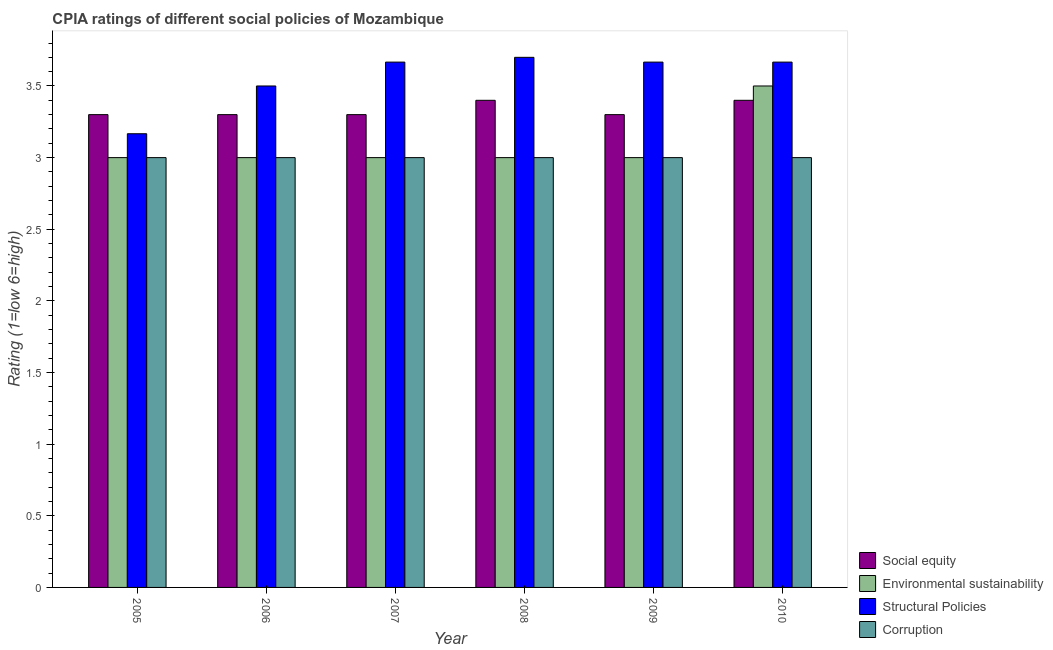How many groups of bars are there?
Give a very brief answer. 6. Are the number of bars per tick equal to the number of legend labels?
Make the answer very short. Yes. Are the number of bars on each tick of the X-axis equal?
Offer a very short reply. Yes. How many bars are there on the 2nd tick from the right?
Ensure brevity in your answer.  4. What is the label of the 4th group of bars from the left?
Your answer should be very brief. 2008. What is the cpia rating of structural policies in 2006?
Offer a very short reply. 3.5. Across all years, what is the maximum cpia rating of corruption?
Provide a succinct answer. 3. Across all years, what is the minimum cpia rating of corruption?
Your answer should be very brief. 3. What is the difference between the cpia rating of social equity in 2005 and that in 2010?
Give a very brief answer. -0.1. What is the difference between the cpia rating of social equity in 2007 and the cpia rating of corruption in 2006?
Offer a very short reply. 0. What is the average cpia rating of structural policies per year?
Ensure brevity in your answer.  3.56. In how many years, is the cpia rating of structural policies greater than 1.7?
Offer a terse response. 6. Is the cpia rating of corruption in 2009 less than that in 2010?
Provide a short and direct response. No. Is the difference between the cpia rating of environmental sustainability in 2008 and 2009 greater than the difference between the cpia rating of social equity in 2008 and 2009?
Provide a short and direct response. No. What is the difference between the highest and the lowest cpia rating of corruption?
Ensure brevity in your answer.  0. What does the 3rd bar from the left in 2005 represents?
Provide a short and direct response. Structural Policies. What does the 4th bar from the right in 2005 represents?
Ensure brevity in your answer.  Social equity. How many bars are there?
Your answer should be compact. 24. How many years are there in the graph?
Give a very brief answer. 6. Does the graph contain any zero values?
Offer a terse response. No. Does the graph contain grids?
Provide a succinct answer. No. What is the title of the graph?
Provide a succinct answer. CPIA ratings of different social policies of Mozambique. Does "Belgium" appear as one of the legend labels in the graph?
Your answer should be very brief. No. What is the Rating (1=low 6=high) of Environmental sustainability in 2005?
Offer a terse response. 3. What is the Rating (1=low 6=high) in Structural Policies in 2005?
Keep it short and to the point. 3.17. What is the Rating (1=low 6=high) of Corruption in 2005?
Give a very brief answer. 3. What is the Rating (1=low 6=high) of Social equity in 2006?
Your answer should be compact. 3.3. What is the Rating (1=low 6=high) of Environmental sustainability in 2006?
Offer a very short reply. 3. What is the Rating (1=low 6=high) of Structural Policies in 2006?
Keep it short and to the point. 3.5. What is the Rating (1=low 6=high) of Corruption in 2006?
Provide a succinct answer. 3. What is the Rating (1=low 6=high) in Social equity in 2007?
Provide a short and direct response. 3.3. What is the Rating (1=low 6=high) in Environmental sustainability in 2007?
Your answer should be compact. 3. What is the Rating (1=low 6=high) of Structural Policies in 2007?
Make the answer very short. 3.67. What is the Rating (1=low 6=high) of Environmental sustainability in 2009?
Offer a very short reply. 3. What is the Rating (1=low 6=high) in Structural Policies in 2009?
Your response must be concise. 3.67. What is the Rating (1=low 6=high) in Social equity in 2010?
Your answer should be very brief. 3.4. What is the Rating (1=low 6=high) in Environmental sustainability in 2010?
Your answer should be compact. 3.5. What is the Rating (1=low 6=high) of Structural Policies in 2010?
Ensure brevity in your answer.  3.67. What is the Rating (1=low 6=high) in Corruption in 2010?
Your response must be concise. 3. Across all years, what is the maximum Rating (1=low 6=high) of Social equity?
Provide a succinct answer. 3.4. Across all years, what is the maximum Rating (1=low 6=high) in Environmental sustainability?
Your answer should be compact. 3.5. Across all years, what is the maximum Rating (1=low 6=high) in Structural Policies?
Your response must be concise. 3.7. Across all years, what is the minimum Rating (1=low 6=high) in Social equity?
Make the answer very short. 3.3. Across all years, what is the minimum Rating (1=low 6=high) of Environmental sustainability?
Ensure brevity in your answer.  3. Across all years, what is the minimum Rating (1=low 6=high) in Structural Policies?
Provide a succinct answer. 3.17. Across all years, what is the minimum Rating (1=low 6=high) in Corruption?
Your answer should be compact. 3. What is the total Rating (1=low 6=high) of Environmental sustainability in the graph?
Your response must be concise. 18.5. What is the total Rating (1=low 6=high) in Structural Policies in the graph?
Ensure brevity in your answer.  21.37. What is the difference between the Rating (1=low 6=high) of Social equity in 2005 and that in 2006?
Your answer should be compact. 0. What is the difference between the Rating (1=low 6=high) in Structural Policies in 2005 and that in 2006?
Provide a short and direct response. -0.33. What is the difference between the Rating (1=low 6=high) in Corruption in 2005 and that in 2006?
Offer a very short reply. 0. What is the difference between the Rating (1=low 6=high) in Social equity in 2005 and that in 2007?
Your answer should be compact. 0. What is the difference between the Rating (1=low 6=high) in Structural Policies in 2005 and that in 2008?
Your response must be concise. -0.53. What is the difference between the Rating (1=low 6=high) of Corruption in 2005 and that in 2008?
Give a very brief answer. 0. What is the difference between the Rating (1=low 6=high) of Structural Policies in 2005 and that in 2009?
Give a very brief answer. -0.5. What is the difference between the Rating (1=low 6=high) in Corruption in 2005 and that in 2009?
Your answer should be compact. 0. What is the difference between the Rating (1=low 6=high) of Corruption in 2005 and that in 2010?
Keep it short and to the point. 0. What is the difference between the Rating (1=low 6=high) of Environmental sustainability in 2006 and that in 2007?
Ensure brevity in your answer.  0. What is the difference between the Rating (1=low 6=high) of Structural Policies in 2006 and that in 2007?
Keep it short and to the point. -0.17. What is the difference between the Rating (1=low 6=high) in Corruption in 2006 and that in 2007?
Provide a short and direct response. 0. What is the difference between the Rating (1=low 6=high) in Corruption in 2006 and that in 2008?
Provide a short and direct response. 0. What is the difference between the Rating (1=low 6=high) in Environmental sustainability in 2006 and that in 2009?
Offer a terse response. 0. What is the difference between the Rating (1=low 6=high) of Structural Policies in 2006 and that in 2009?
Offer a very short reply. -0.17. What is the difference between the Rating (1=low 6=high) in Environmental sustainability in 2006 and that in 2010?
Keep it short and to the point. -0.5. What is the difference between the Rating (1=low 6=high) in Structural Policies in 2007 and that in 2008?
Make the answer very short. -0.03. What is the difference between the Rating (1=low 6=high) of Structural Policies in 2007 and that in 2009?
Offer a terse response. 0. What is the difference between the Rating (1=low 6=high) of Structural Policies in 2007 and that in 2010?
Offer a very short reply. 0. What is the difference between the Rating (1=low 6=high) of Corruption in 2007 and that in 2010?
Provide a short and direct response. 0. What is the difference between the Rating (1=low 6=high) of Environmental sustainability in 2008 and that in 2009?
Offer a very short reply. 0. What is the difference between the Rating (1=low 6=high) of Environmental sustainability in 2008 and that in 2010?
Keep it short and to the point. -0.5. What is the difference between the Rating (1=low 6=high) of Structural Policies in 2008 and that in 2010?
Your answer should be compact. 0.03. What is the difference between the Rating (1=low 6=high) in Social equity in 2009 and that in 2010?
Your response must be concise. -0.1. What is the difference between the Rating (1=low 6=high) in Environmental sustainability in 2009 and that in 2010?
Provide a short and direct response. -0.5. What is the difference between the Rating (1=low 6=high) of Structural Policies in 2009 and that in 2010?
Offer a very short reply. 0. What is the difference between the Rating (1=low 6=high) of Corruption in 2009 and that in 2010?
Your answer should be compact. 0. What is the difference between the Rating (1=low 6=high) of Social equity in 2005 and the Rating (1=low 6=high) of Structural Policies in 2006?
Make the answer very short. -0.2. What is the difference between the Rating (1=low 6=high) in Social equity in 2005 and the Rating (1=low 6=high) in Corruption in 2006?
Your answer should be compact. 0.3. What is the difference between the Rating (1=low 6=high) of Structural Policies in 2005 and the Rating (1=low 6=high) of Corruption in 2006?
Give a very brief answer. 0.17. What is the difference between the Rating (1=low 6=high) of Social equity in 2005 and the Rating (1=low 6=high) of Structural Policies in 2007?
Offer a very short reply. -0.37. What is the difference between the Rating (1=low 6=high) of Environmental sustainability in 2005 and the Rating (1=low 6=high) of Structural Policies in 2007?
Offer a very short reply. -0.67. What is the difference between the Rating (1=low 6=high) in Structural Policies in 2005 and the Rating (1=low 6=high) in Corruption in 2007?
Give a very brief answer. 0.17. What is the difference between the Rating (1=low 6=high) in Environmental sustainability in 2005 and the Rating (1=low 6=high) in Structural Policies in 2008?
Your answer should be compact. -0.7. What is the difference between the Rating (1=low 6=high) in Environmental sustainability in 2005 and the Rating (1=low 6=high) in Corruption in 2008?
Your response must be concise. 0. What is the difference between the Rating (1=low 6=high) of Social equity in 2005 and the Rating (1=low 6=high) of Structural Policies in 2009?
Make the answer very short. -0.37. What is the difference between the Rating (1=low 6=high) of Social equity in 2005 and the Rating (1=low 6=high) of Structural Policies in 2010?
Give a very brief answer. -0.37. What is the difference between the Rating (1=low 6=high) of Environmental sustainability in 2005 and the Rating (1=low 6=high) of Structural Policies in 2010?
Your response must be concise. -0.67. What is the difference between the Rating (1=low 6=high) in Structural Policies in 2005 and the Rating (1=low 6=high) in Corruption in 2010?
Offer a very short reply. 0.17. What is the difference between the Rating (1=low 6=high) of Social equity in 2006 and the Rating (1=low 6=high) of Environmental sustainability in 2007?
Your answer should be very brief. 0.3. What is the difference between the Rating (1=low 6=high) in Social equity in 2006 and the Rating (1=low 6=high) in Structural Policies in 2007?
Make the answer very short. -0.37. What is the difference between the Rating (1=low 6=high) of Social equity in 2006 and the Rating (1=low 6=high) of Corruption in 2007?
Offer a very short reply. 0.3. What is the difference between the Rating (1=low 6=high) in Social equity in 2006 and the Rating (1=low 6=high) in Structural Policies in 2008?
Make the answer very short. -0.4. What is the difference between the Rating (1=low 6=high) in Structural Policies in 2006 and the Rating (1=low 6=high) in Corruption in 2008?
Your response must be concise. 0.5. What is the difference between the Rating (1=low 6=high) of Social equity in 2006 and the Rating (1=low 6=high) of Structural Policies in 2009?
Provide a succinct answer. -0.37. What is the difference between the Rating (1=low 6=high) in Environmental sustainability in 2006 and the Rating (1=low 6=high) in Structural Policies in 2009?
Your response must be concise. -0.67. What is the difference between the Rating (1=low 6=high) in Environmental sustainability in 2006 and the Rating (1=low 6=high) in Corruption in 2009?
Provide a succinct answer. 0. What is the difference between the Rating (1=low 6=high) in Social equity in 2006 and the Rating (1=low 6=high) in Environmental sustainability in 2010?
Your answer should be very brief. -0.2. What is the difference between the Rating (1=low 6=high) of Social equity in 2006 and the Rating (1=low 6=high) of Structural Policies in 2010?
Your answer should be very brief. -0.37. What is the difference between the Rating (1=low 6=high) in Environmental sustainability in 2006 and the Rating (1=low 6=high) in Structural Policies in 2010?
Your answer should be very brief. -0.67. What is the difference between the Rating (1=low 6=high) in Environmental sustainability in 2006 and the Rating (1=low 6=high) in Corruption in 2010?
Ensure brevity in your answer.  0. What is the difference between the Rating (1=low 6=high) of Structural Policies in 2006 and the Rating (1=low 6=high) of Corruption in 2010?
Offer a terse response. 0.5. What is the difference between the Rating (1=low 6=high) in Social equity in 2007 and the Rating (1=low 6=high) in Environmental sustainability in 2008?
Give a very brief answer. 0.3. What is the difference between the Rating (1=low 6=high) of Social equity in 2007 and the Rating (1=low 6=high) of Structural Policies in 2008?
Your answer should be very brief. -0.4. What is the difference between the Rating (1=low 6=high) of Structural Policies in 2007 and the Rating (1=low 6=high) of Corruption in 2008?
Make the answer very short. 0.67. What is the difference between the Rating (1=low 6=high) in Social equity in 2007 and the Rating (1=low 6=high) in Environmental sustainability in 2009?
Make the answer very short. 0.3. What is the difference between the Rating (1=low 6=high) of Social equity in 2007 and the Rating (1=low 6=high) of Structural Policies in 2009?
Make the answer very short. -0.37. What is the difference between the Rating (1=low 6=high) of Environmental sustainability in 2007 and the Rating (1=low 6=high) of Structural Policies in 2009?
Provide a short and direct response. -0.67. What is the difference between the Rating (1=low 6=high) of Structural Policies in 2007 and the Rating (1=low 6=high) of Corruption in 2009?
Ensure brevity in your answer.  0.67. What is the difference between the Rating (1=low 6=high) in Social equity in 2007 and the Rating (1=low 6=high) in Structural Policies in 2010?
Offer a very short reply. -0.37. What is the difference between the Rating (1=low 6=high) in Environmental sustainability in 2007 and the Rating (1=low 6=high) in Structural Policies in 2010?
Offer a very short reply. -0.67. What is the difference between the Rating (1=low 6=high) of Structural Policies in 2007 and the Rating (1=low 6=high) of Corruption in 2010?
Keep it short and to the point. 0.67. What is the difference between the Rating (1=low 6=high) in Social equity in 2008 and the Rating (1=low 6=high) in Environmental sustainability in 2009?
Offer a very short reply. 0.4. What is the difference between the Rating (1=low 6=high) in Social equity in 2008 and the Rating (1=low 6=high) in Structural Policies in 2009?
Your answer should be very brief. -0.27. What is the difference between the Rating (1=low 6=high) in Social equity in 2008 and the Rating (1=low 6=high) in Corruption in 2009?
Give a very brief answer. 0.4. What is the difference between the Rating (1=low 6=high) in Environmental sustainability in 2008 and the Rating (1=low 6=high) in Structural Policies in 2009?
Your response must be concise. -0.67. What is the difference between the Rating (1=low 6=high) in Structural Policies in 2008 and the Rating (1=low 6=high) in Corruption in 2009?
Give a very brief answer. 0.7. What is the difference between the Rating (1=low 6=high) in Social equity in 2008 and the Rating (1=low 6=high) in Environmental sustainability in 2010?
Provide a short and direct response. -0.1. What is the difference between the Rating (1=low 6=high) of Social equity in 2008 and the Rating (1=low 6=high) of Structural Policies in 2010?
Your answer should be very brief. -0.27. What is the difference between the Rating (1=low 6=high) of Environmental sustainability in 2008 and the Rating (1=low 6=high) of Structural Policies in 2010?
Your answer should be compact. -0.67. What is the difference between the Rating (1=low 6=high) in Environmental sustainability in 2008 and the Rating (1=low 6=high) in Corruption in 2010?
Your answer should be very brief. 0. What is the difference between the Rating (1=low 6=high) of Social equity in 2009 and the Rating (1=low 6=high) of Structural Policies in 2010?
Your answer should be very brief. -0.37. What is the difference between the Rating (1=low 6=high) in Social equity in 2009 and the Rating (1=low 6=high) in Corruption in 2010?
Your response must be concise. 0.3. What is the average Rating (1=low 6=high) of Environmental sustainability per year?
Your answer should be compact. 3.08. What is the average Rating (1=low 6=high) of Structural Policies per year?
Ensure brevity in your answer.  3.56. In the year 2005, what is the difference between the Rating (1=low 6=high) in Social equity and Rating (1=low 6=high) in Structural Policies?
Offer a very short reply. 0.13. In the year 2005, what is the difference between the Rating (1=low 6=high) of Environmental sustainability and Rating (1=low 6=high) of Structural Policies?
Keep it short and to the point. -0.17. In the year 2005, what is the difference between the Rating (1=low 6=high) in Structural Policies and Rating (1=low 6=high) in Corruption?
Provide a succinct answer. 0.17. In the year 2006, what is the difference between the Rating (1=low 6=high) in Social equity and Rating (1=low 6=high) in Corruption?
Make the answer very short. 0.3. In the year 2006, what is the difference between the Rating (1=low 6=high) of Environmental sustainability and Rating (1=low 6=high) of Structural Policies?
Ensure brevity in your answer.  -0.5. In the year 2006, what is the difference between the Rating (1=low 6=high) in Structural Policies and Rating (1=low 6=high) in Corruption?
Keep it short and to the point. 0.5. In the year 2007, what is the difference between the Rating (1=low 6=high) in Social equity and Rating (1=low 6=high) in Environmental sustainability?
Ensure brevity in your answer.  0.3. In the year 2007, what is the difference between the Rating (1=low 6=high) in Social equity and Rating (1=low 6=high) in Structural Policies?
Offer a terse response. -0.37. In the year 2008, what is the difference between the Rating (1=low 6=high) of Social equity and Rating (1=low 6=high) of Environmental sustainability?
Offer a terse response. 0.4. In the year 2008, what is the difference between the Rating (1=low 6=high) of Social equity and Rating (1=low 6=high) of Structural Policies?
Your answer should be compact. -0.3. In the year 2008, what is the difference between the Rating (1=low 6=high) in Environmental sustainability and Rating (1=low 6=high) in Structural Policies?
Offer a terse response. -0.7. In the year 2008, what is the difference between the Rating (1=low 6=high) of Environmental sustainability and Rating (1=low 6=high) of Corruption?
Provide a short and direct response. 0. In the year 2008, what is the difference between the Rating (1=low 6=high) of Structural Policies and Rating (1=low 6=high) of Corruption?
Provide a succinct answer. 0.7. In the year 2009, what is the difference between the Rating (1=low 6=high) in Social equity and Rating (1=low 6=high) in Structural Policies?
Ensure brevity in your answer.  -0.37. In the year 2009, what is the difference between the Rating (1=low 6=high) of Environmental sustainability and Rating (1=low 6=high) of Corruption?
Offer a very short reply. 0. In the year 2009, what is the difference between the Rating (1=low 6=high) in Structural Policies and Rating (1=low 6=high) in Corruption?
Offer a terse response. 0.67. In the year 2010, what is the difference between the Rating (1=low 6=high) of Social equity and Rating (1=low 6=high) of Structural Policies?
Offer a very short reply. -0.27. In the year 2010, what is the difference between the Rating (1=low 6=high) of Social equity and Rating (1=low 6=high) of Corruption?
Your answer should be compact. 0.4. In the year 2010, what is the difference between the Rating (1=low 6=high) in Environmental sustainability and Rating (1=low 6=high) in Corruption?
Your response must be concise. 0.5. In the year 2010, what is the difference between the Rating (1=low 6=high) of Structural Policies and Rating (1=low 6=high) of Corruption?
Provide a short and direct response. 0.67. What is the ratio of the Rating (1=low 6=high) of Social equity in 2005 to that in 2006?
Provide a succinct answer. 1. What is the ratio of the Rating (1=low 6=high) of Environmental sustainability in 2005 to that in 2006?
Provide a short and direct response. 1. What is the ratio of the Rating (1=low 6=high) in Structural Policies in 2005 to that in 2006?
Ensure brevity in your answer.  0.9. What is the ratio of the Rating (1=low 6=high) in Social equity in 2005 to that in 2007?
Your response must be concise. 1. What is the ratio of the Rating (1=low 6=high) in Structural Policies in 2005 to that in 2007?
Make the answer very short. 0.86. What is the ratio of the Rating (1=low 6=high) in Corruption in 2005 to that in 2007?
Offer a very short reply. 1. What is the ratio of the Rating (1=low 6=high) of Social equity in 2005 to that in 2008?
Provide a succinct answer. 0.97. What is the ratio of the Rating (1=low 6=high) of Structural Policies in 2005 to that in 2008?
Ensure brevity in your answer.  0.86. What is the ratio of the Rating (1=low 6=high) of Corruption in 2005 to that in 2008?
Provide a succinct answer. 1. What is the ratio of the Rating (1=low 6=high) in Environmental sustainability in 2005 to that in 2009?
Provide a succinct answer. 1. What is the ratio of the Rating (1=low 6=high) in Structural Policies in 2005 to that in 2009?
Offer a very short reply. 0.86. What is the ratio of the Rating (1=low 6=high) in Social equity in 2005 to that in 2010?
Give a very brief answer. 0.97. What is the ratio of the Rating (1=low 6=high) of Structural Policies in 2005 to that in 2010?
Give a very brief answer. 0.86. What is the ratio of the Rating (1=low 6=high) in Social equity in 2006 to that in 2007?
Your response must be concise. 1. What is the ratio of the Rating (1=low 6=high) in Structural Policies in 2006 to that in 2007?
Your response must be concise. 0.95. What is the ratio of the Rating (1=low 6=high) of Corruption in 2006 to that in 2007?
Your response must be concise. 1. What is the ratio of the Rating (1=low 6=high) in Social equity in 2006 to that in 2008?
Provide a succinct answer. 0.97. What is the ratio of the Rating (1=low 6=high) of Environmental sustainability in 2006 to that in 2008?
Keep it short and to the point. 1. What is the ratio of the Rating (1=low 6=high) of Structural Policies in 2006 to that in 2008?
Give a very brief answer. 0.95. What is the ratio of the Rating (1=low 6=high) of Corruption in 2006 to that in 2008?
Provide a succinct answer. 1. What is the ratio of the Rating (1=low 6=high) in Structural Policies in 2006 to that in 2009?
Offer a very short reply. 0.95. What is the ratio of the Rating (1=low 6=high) of Corruption in 2006 to that in 2009?
Keep it short and to the point. 1. What is the ratio of the Rating (1=low 6=high) in Social equity in 2006 to that in 2010?
Your answer should be compact. 0.97. What is the ratio of the Rating (1=low 6=high) in Structural Policies in 2006 to that in 2010?
Provide a succinct answer. 0.95. What is the ratio of the Rating (1=low 6=high) of Corruption in 2006 to that in 2010?
Make the answer very short. 1. What is the ratio of the Rating (1=low 6=high) of Social equity in 2007 to that in 2008?
Your response must be concise. 0.97. What is the ratio of the Rating (1=low 6=high) in Structural Policies in 2007 to that in 2008?
Offer a very short reply. 0.99. What is the ratio of the Rating (1=low 6=high) in Social equity in 2007 to that in 2010?
Keep it short and to the point. 0.97. What is the ratio of the Rating (1=low 6=high) in Structural Policies in 2007 to that in 2010?
Make the answer very short. 1. What is the ratio of the Rating (1=low 6=high) of Social equity in 2008 to that in 2009?
Offer a terse response. 1.03. What is the ratio of the Rating (1=low 6=high) in Environmental sustainability in 2008 to that in 2009?
Provide a short and direct response. 1. What is the ratio of the Rating (1=low 6=high) of Structural Policies in 2008 to that in 2009?
Offer a terse response. 1.01. What is the ratio of the Rating (1=low 6=high) of Corruption in 2008 to that in 2009?
Your response must be concise. 1. What is the ratio of the Rating (1=low 6=high) in Structural Policies in 2008 to that in 2010?
Ensure brevity in your answer.  1.01. What is the ratio of the Rating (1=low 6=high) of Corruption in 2008 to that in 2010?
Offer a terse response. 1. What is the ratio of the Rating (1=low 6=high) in Social equity in 2009 to that in 2010?
Make the answer very short. 0.97. What is the ratio of the Rating (1=low 6=high) in Environmental sustainability in 2009 to that in 2010?
Your answer should be very brief. 0.86. What is the difference between the highest and the second highest Rating (1=low 6=high) of Structural Policies?
Provide a succinct answer. 0.03. What is the difference between the highest and the lowest Rating (1=low 6=high) of Social equity?
Give a very brief answer. 0.1. What is the difference between the highest and the lowest Rating (1=low 6=high) of Environmental sustainability?
Provide a short and direct response. 0.5. What is the difference between the highest and the lowest Rating (1=low 6=high) in Structural Policies?
Make the answer very short. 0.53. 